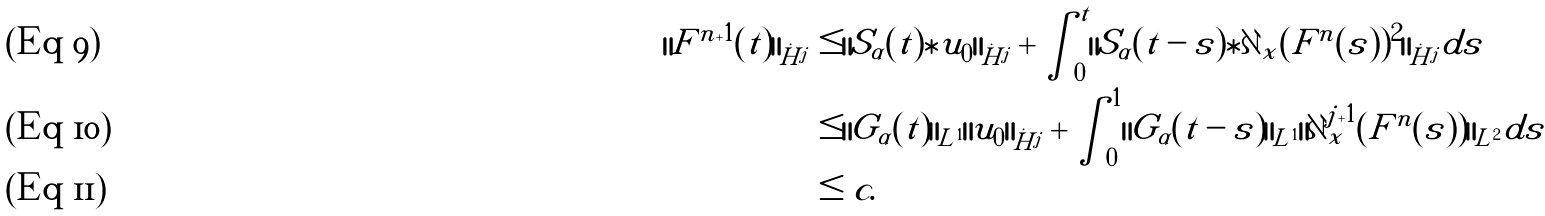Convert formula to latex. <formula><loc_0><loc_0><loc_500><loc_500>\| F ^ { n + 1 } ( t ) \| _ { \dot { H } ^ { j } } & \leq \| S _ { \alpha } ( t ) \ast u _ { 0 } \| _ { \dot { H } ^ { j } } + \int _ { 0 } ^ { t } \| S _ { \alpha } ( t - s ) \ast \partial _ { x } ( F ^ { n } ( s ) ) ^ { 2 } \| _ { \dot { H } ^ { j } } d s \\ & \leq \| G _ { \alpha } ( t ) \| _ { L ^ { 1 } } \| u _ { 0 } \| _ { \dot { H } ^ { j } } + \int _ { 0 } ^ { 1 } \| G _ { \alpha } ( t - s ) \| _ { L ^ { 1 } } \| \partial _ { x } ^ { j + 1 } ( F ^ { n } ( s ) ) \| _ { L ^ { 2 } } d s \\ & \leq c .</formula> 